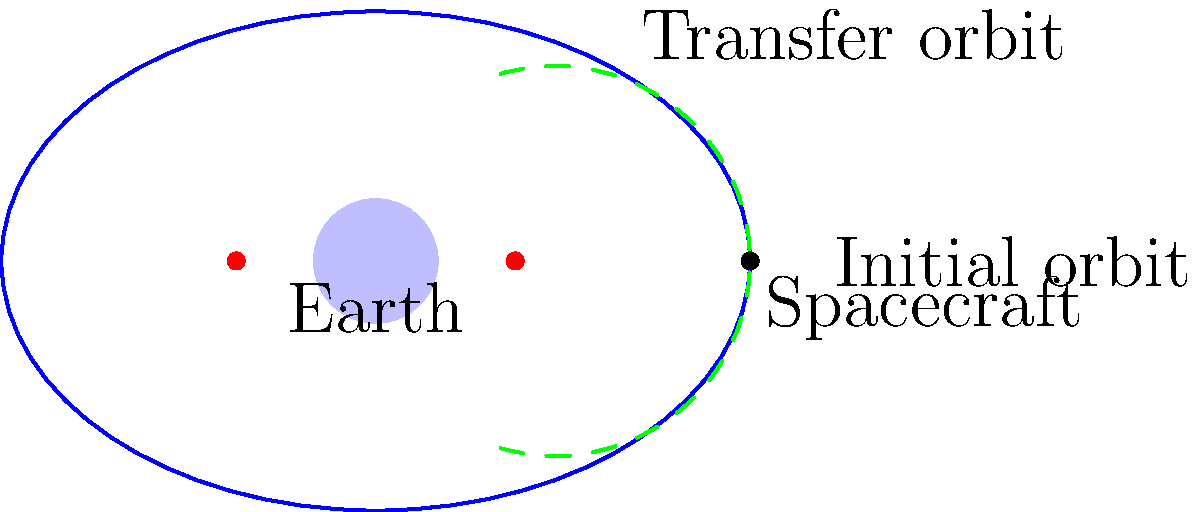In a mission to optimize a spacecraft's trajectory, you need to design a Hohmann transfer orbit to move the spacecraft from its initial circular orbit to a higher elliptical orbit around Earth. The initial orbit has a radius of 3 units, and the target elliptical orbit has a semi-major axis of 4 units and an eccentricity of 0.5. What is the change in velocity (Δv) required at the periapsis of the transfer orbit to initiate the maneuver? To solve this problem, we'll follow these steps:

1) First, let's recall the vis-viva equation: $$v^2 = GM(\frac{2}{r} - \frac{1}{a})$$
   where v is velocity, G is the gravitational constant, M is the mass of Earth, r is the distance from the center of Earth, and a is the semi-major axis of the orbit.

2) For the initial circular orbit:
   $$v_1^2 = \frac{GM}{r_1}$$ (since for a circular orbit, r = a)
   where $r_1 = 3$ units

3) For the transfer orbit at periapsis (which is the same as the initial orbit radius):
   $$v_p^2 = GM(\frac{2}{r_1} - \frac{1}{a_t})$$
   where $a_t$ is the semi-major axis of the transfer orbit

4) The semi-major axis of the transfer orbit is the average of the radii of the initial and final orbits:
   $$a_t = \frac{r_1 + a_f}{2} = \frac{3 + 4}{2} = 3.5$$ units

5) Now we can calculate the velocity change needed at periapsis:
   $$\Delta v = v_p - v_1 = \sqrt{GM(\frac{2}{r_1} - \frac{1}{a_t})} - \sqrt{\frac{GM}{r_1}}$$

6) Substituting the values:
   $$\Delta v = \sqrt{GM(\frac{2}{3} - \frac{1}{3.5})} - \sqrt{\frac{GM}{3}}$$

7) Simplifying (assuming GM = 1 for unit simplification):
   $$\Delta v = \sqrt{\frac{2}{3} - \frac{1}{3.5}} - \sqrt{\frac{1}{3}} \approx 0.1349$$ units/time

Therefore, the change in velocity required at the periapsis of the transfer orbit is approximately 0.1349 units/time.
Answer: 0.1349 units/time 